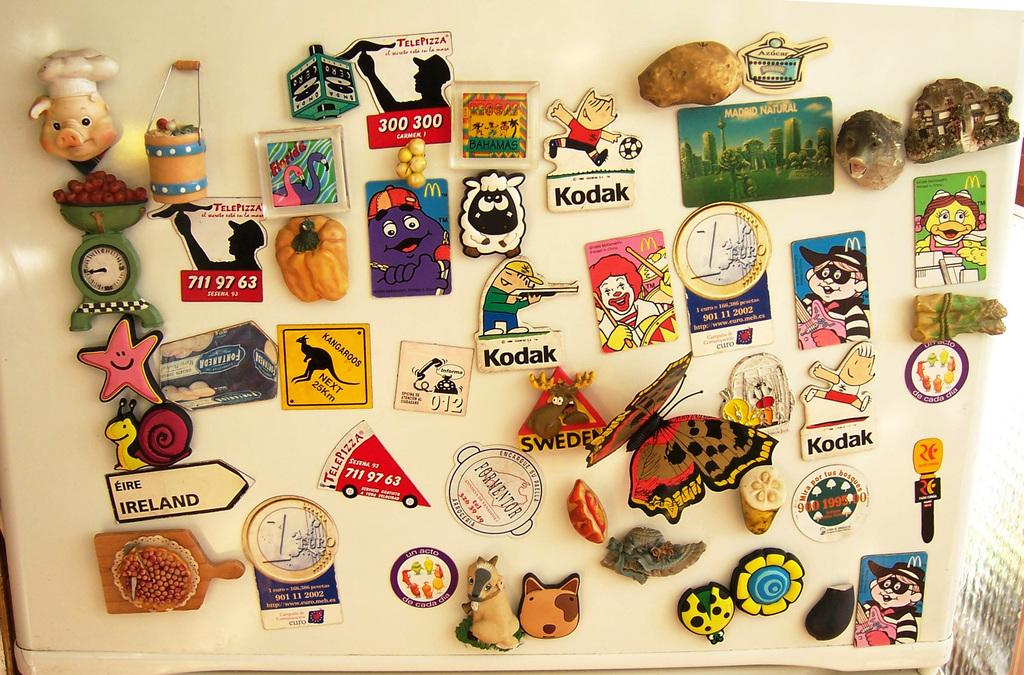What is located in the center of the image? There are stickers in the center of the image. What types of images are featured on the stickers? The stickers include animals and vegetables. What flavor of snow can be seen in the image? There is no snow present in the image, so it is not possible to determine the flavor of any snow. 